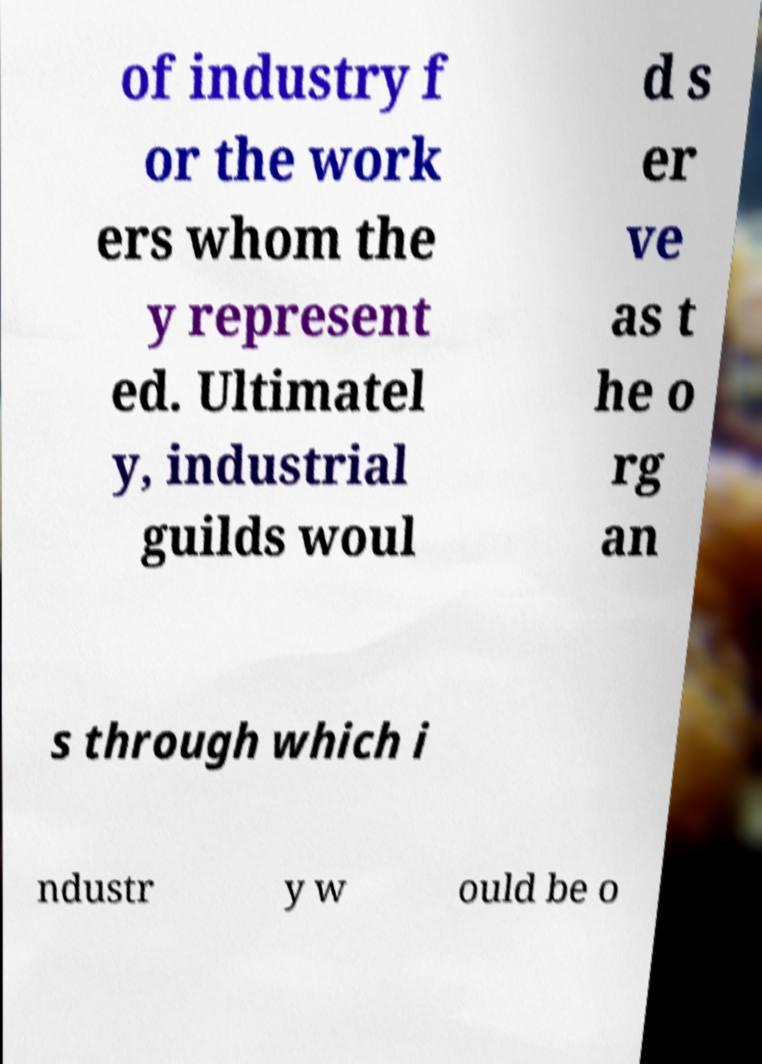Could you extract and type out the text from this image? of industry f or the work ers whom the y represent ed. Ultimatel y, industrial guilds woul d s er ve as t he o rg an s through which i ndustr y w ould be o 